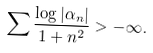Convert formula to latex. <formula><loc_0><loc_0><loc_500><loc_500>\sum \frac { \log | \alpha _ { n } | } { 1 + n ^ { 2 } } > - \infty .</formula> 